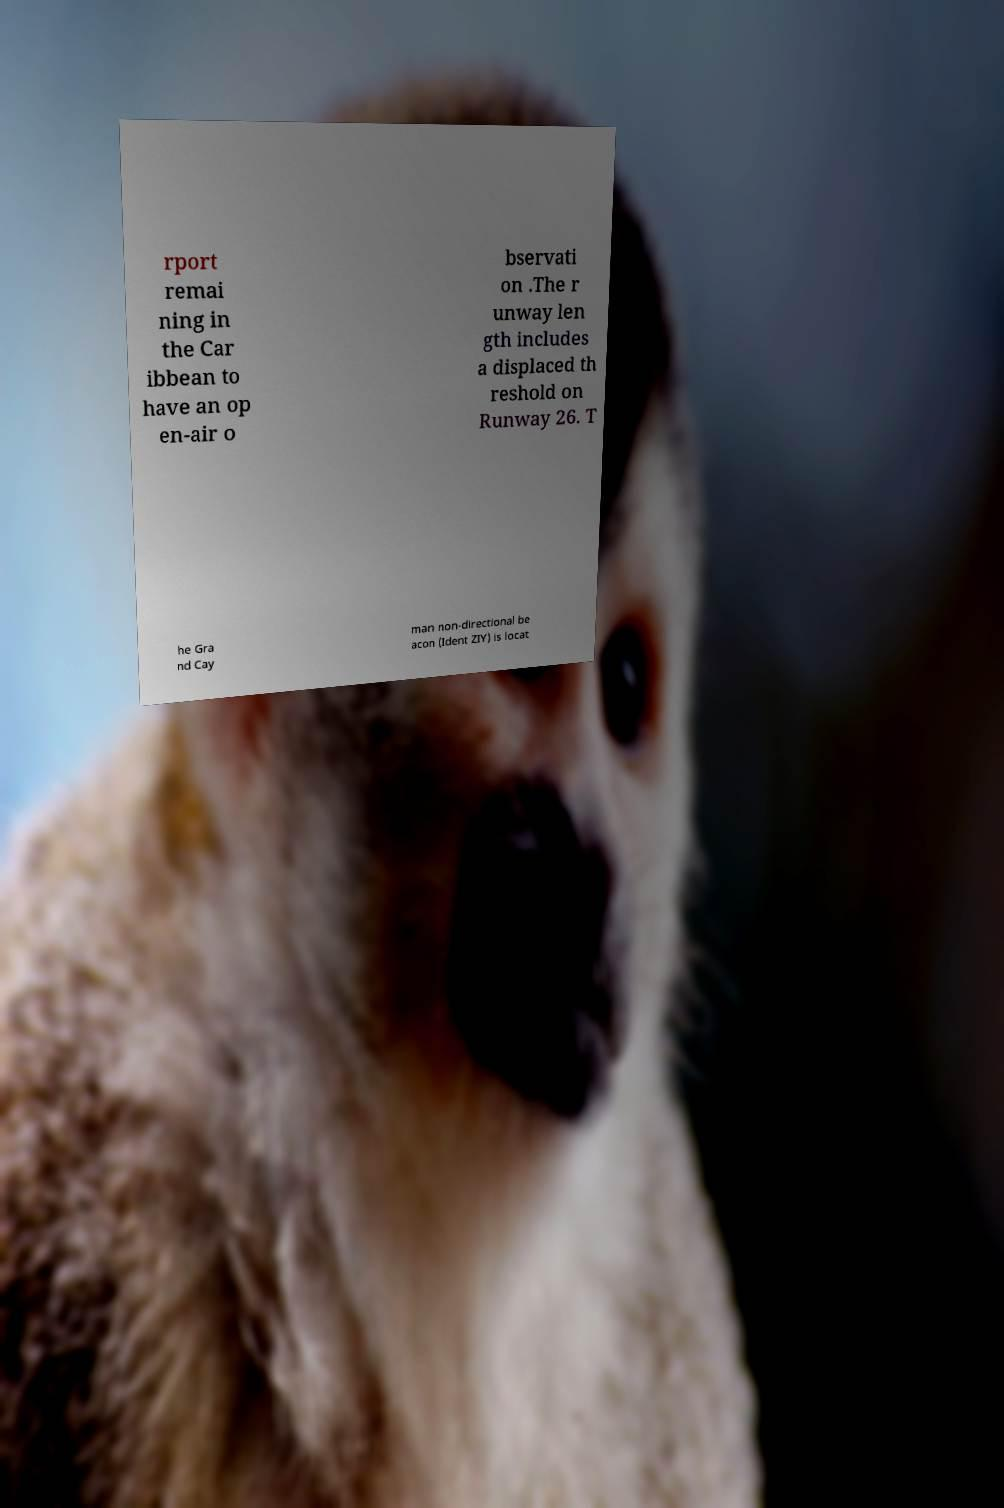Could you extract and type out the text from this image? rport remai ning in the Car ibbean to have an op en-air o bservati on .The r unway len gth includes a displaced th reshold on Runway 26. T he Gra nd Cay man non-directional be acon (Ident ZIY) is locat 